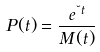<formula> <loc_0><loc_0><loc_500><loc_500>P ( t ) = \frac { e { ^ { \lambda t } } } { M ( t ) }</formula> 